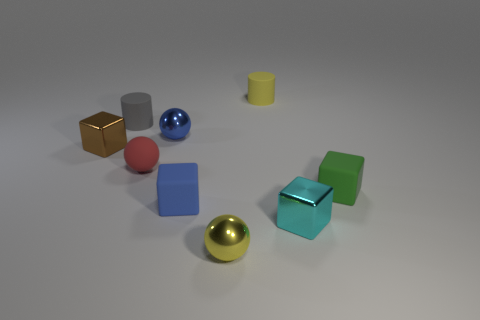Subtract all cyan cubes. How many cubes are left? 3 Add 1 tiny cyan balls. How many objects exist? 10 Subtract all brown cubes. How many cubes are left? 3 Subtract all spheres. How many objects are left? 6 Subtract 0 red cubes. How many objects are left? 9 Subtract all purple cubes. Subtract all blue cylinders. How many cubes are left? 4 Subtract all small brown blocks. Subtract all yellow things. How many objects are left? 6 Add 1 red objects. How many red objects are left? 2 Add 4 red things. How many red things exist? 5 